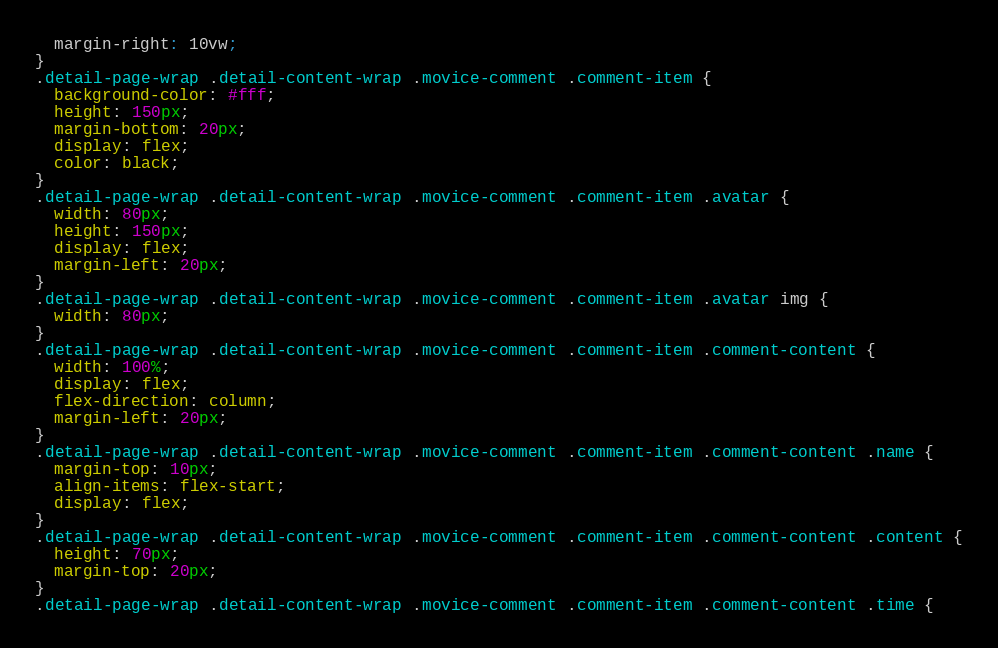Convert code to text. <code><loc_0><loc_0><loc_500><loc_500><_CSS_>  margin-right: 10vw;
}
.detail-page-wrap .detail-content-wrap .movice-comment .comment-item {
  background-color: #fff;
  height: 150px;
  margin-bottom: 20px;
  display: flex;
  color: black;
}
.detail-page-wrap .detail-content-wrap .movice-comment .comment-item .avatar {
  width: 80px;
  height: 150px;
  display: flex;
  margin-left: 20px;
}
.detail-page-wrap .detail-content-wrap .movice-comment .comment-item .avatar img {
  width: 80px;
}
.detail-page-wrap .detail-content-wrap .movice-comment .comment-item .comment-content {
  width: 100%;
  display: flex;
  flex-direction: column;
  margin-left: 20px;
}
.detail-page-wrap .detail-content-wrap .movice-comment .comment-item .comment-content .name {
  margin-top: 10px;
  align-items: flex-start;
  display: flex;
}
.detail-page-wrap .detail-content-wrap .movice-comment .comment-item .comment-content .content {
  height: 70px;
  margin-top: 20px;
}
.detail-page-wrap .detail-content-wrap .movice-comment .comment-item .comment-content .time {</code> 